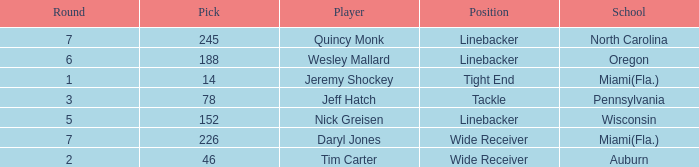From what school was the linebacker that had a pick less than 245 and was drafted in round 6? Oregon. 